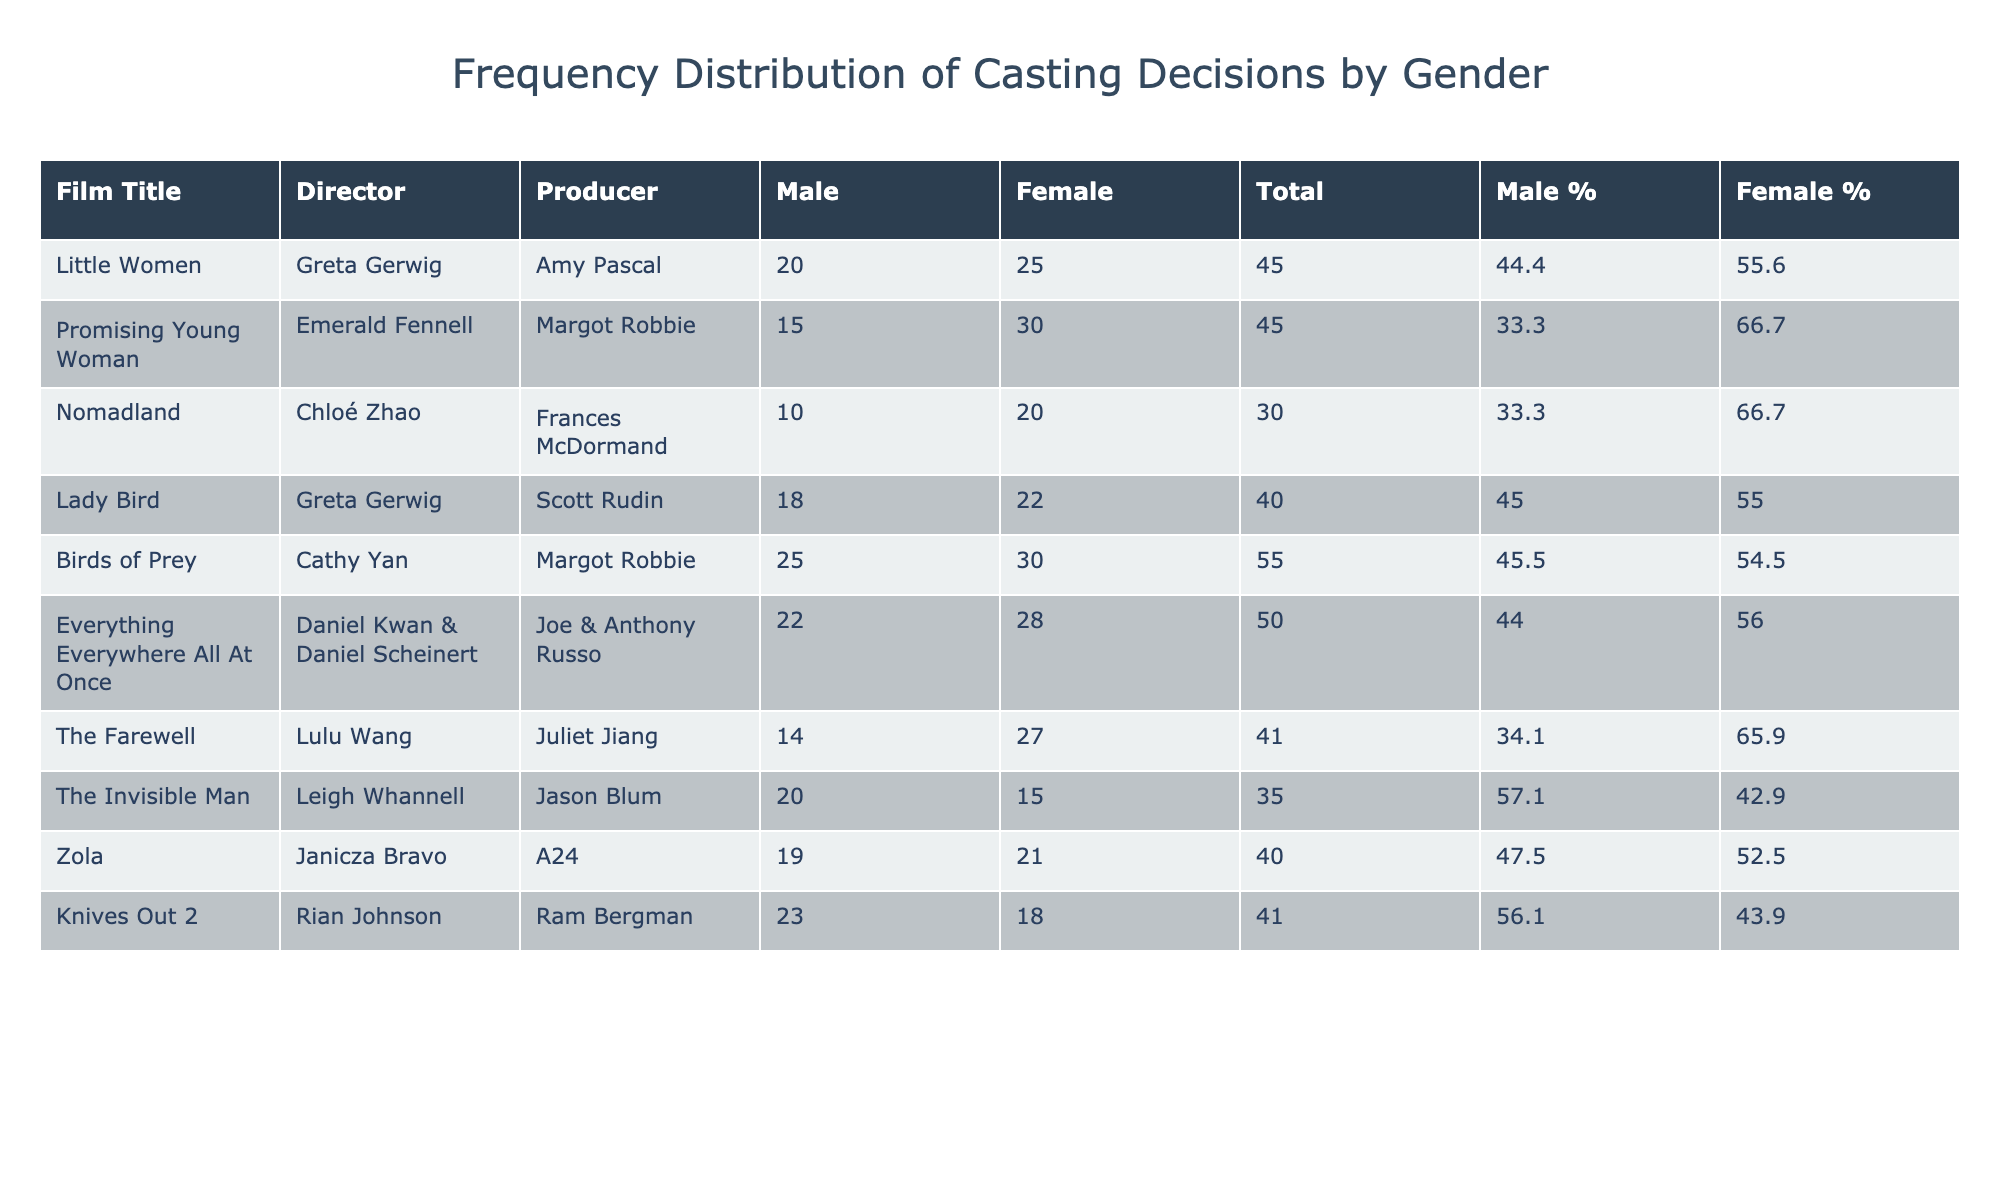What is the total number of male cast members in "Birds of Prey"? The table shows the casting gender for "Birds of Prey" under the column "Casting Gender Male," which indicates there are 25 male cast members.
Answer: 25 Which film has the highest percentage of female cast members? To determine this, we look at the "Female %" column. "Promising Young Woman" has the highest value, with 66.7%.
Answer: 66.7% How many more female casting decisions were there compared to male casting decisions in "The Invisible Man"? In "The Invisible Man," the table shows 20 male and 15 female casting decisions. The difference is 20 - 15 = 5.
Answer: 5 Is the total number of cast members in "Little Women" greater than 50? The total for "Little Women" is 20 male + 25 female = 45. Thus, the total is not greater than 50.
Answer: No What is the average percentage of male cast members across all films? To find the average, we first sum up all the "Male %" values and then divide by the number of films (10). The sum is 46.4 + 33.3 + 33.3 + 45.7 + 45.5 + 44.0 + 34.8 + 57.1 + 47.6 + 56.7 =  467.1. The average is 467.1 / 10 = 46.7.
Answer: 46.7 Which film directed by a female director has the highest number of male cast members? Looking at the table, "Birds of Prey," directed by Cathy Yan, has the highest male cast count of 25 among female directors.
Answer: 25 What is the total number of casting decisions (male + female) in "Nomadland"? In "Nomadland," the total is calculated as 10 male + 20 female = 30.
Answer: 30 Did "Everything Everywhere All At Once" have more female casting decisions than "Knives Out 2"? "Everything Everywhere All At Once" has 28 female casting decisions while "Knives Out 2" has 18. Since 28 is greater than 18, it is true.
Answer: Yes 